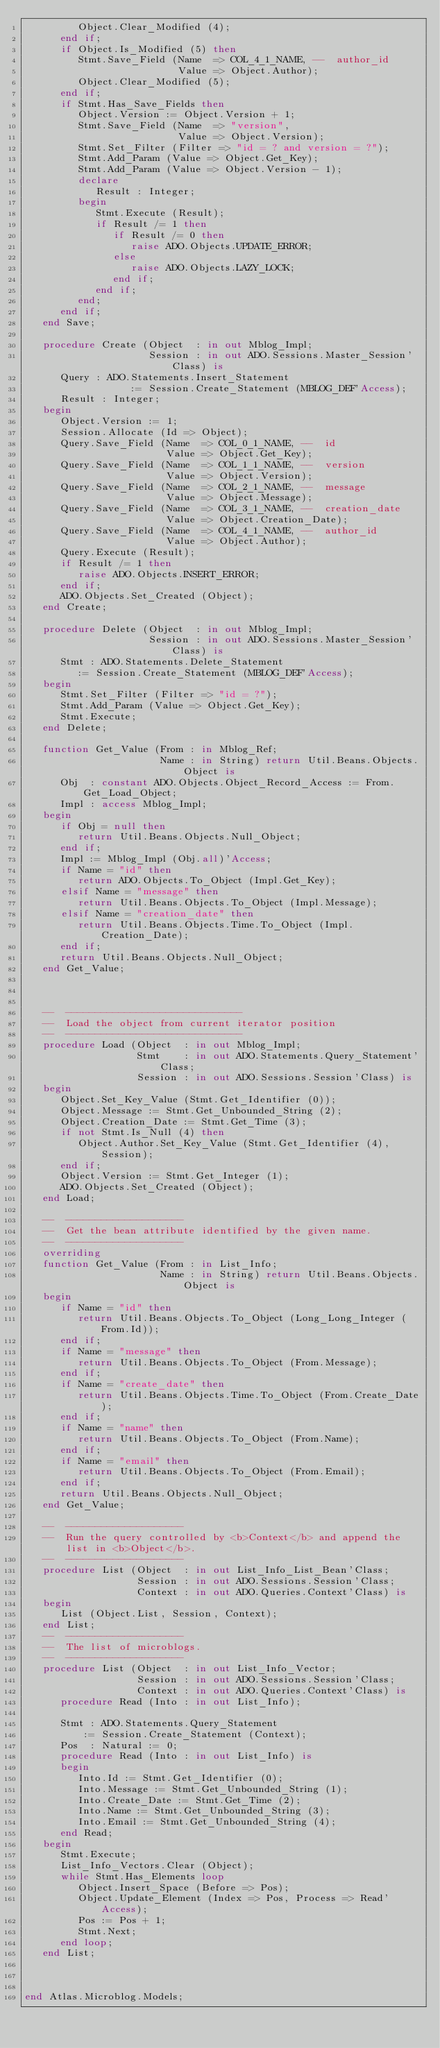Convert code to text. <code><loc_0><loc_0><loc_500><loc_500><_Ada_>         Object.Clear_Modified (4);
      end if;
      if Object.Is_Modified (5) then
         Stmt.Save_Field (Name  => COL_4_1_NAME, --  author_id
                          Value => Object.Author);
         Object.Clear_Modified (5);
      end if;
      if Stmt.Has_Save_Fields then
         Object.Version := Object.Version + 1;
         Stmt.Save_Field (Name  => "version",
                          Value => Object.Version);
         Stmt.Set_Filter (Filter => "id = ? and version = ?");
         Stmt.Add_Param (Value => Object.Get_Key);
         Stmt.Add_Param (Value => Object.Version - 1);
         declare
            Result : Integer;
         begin
            Stmt.Execute (Result);
            if Result /= 1 then
               if Result /= 0 then
                  raise ADO.Objects.UPDATE_ERROR;
               else
                  raise ADO.Objects.LAZY_LOCK;
               end if;
            end if;
         end;
      end if;
   end Save;

   procedure Create (Object  : in out Mblog_Impl;
                     Session : in out ADO.Sessions.Master_Session'Class) is
      Query : ADO.Statements.Insert_Statement
                  := Session.Create_Statement (MBLOG_DEF'Access);
      Result : Integer;
   begin
      Object.Version := 1;
      Session.Allocate (Id => Object);
      Query.Save_Field (Name  => COL_0_1_NAME, --  id
                        Value => Object.Get_Key);
      Query.Save_Field (Name  => COL_1_1_NAME, --  version
                        Value => Object.Version);
      Query.Save_Field (Name  => COL_2_1_NAME, --  message
                        Value => Object.Message);
      Query.Save_Field (Name  => COL_3_1_NAME, --  creation_date
                        Value => Object.Creation_Date);
      Query.Save_Field (Name  => COL_4_1_NAME, --  author_id
                        Value => Object.Author);
      Query.Execute (Result);
      if Result /= 1 then
         raise ADO.Objects.INSERT_ERROR;
      end if;
      ADO.Objects.Set_Created (Object);
   end Create;

   procedure Delete (Object  : in out Mblog_Impl;
                     Session : in out ADO.Sessions.Master_Session'Class) is
      Stmt : ADO.Statements.Delete_Statement
         := Session.Create_Statement (MBLOG_DEF'Access);
   begin
      Stmt.Set_Filter (Filter => "id = ?");
      Stmt.Add_Param (Value => Object.Get_Key);
      Stmt.Execute;
   end Delete;

   function Get_Value (From : in Mblog_Ref;
                       Name : in String) return Util.Beans.Objects.Object is
      Obj  : constant ADO.Objects.Object_Record_Access := From.Get_Load_Object;
      Impl : access Mblog_Impl;
   begin
      if Obj = null then
         return Util.Beans.Objects.Null_Object;
      end if;
      Impl := Mblog_Impl (Obj.all)'Access;
      if Name = "id" then
         return ADO.Objects.To_Object (Impl.Get_Key);
      elsif Name = "message" then
         return Util.Beans.Objects.To_Object (Impl.Message);
      elsif Name = "creation_date" then
         return Util.Beans.Objects.Time.To_Object (Impl.Creation_Date);
      end if;
      return Util.Beans.Objects.Null_Object;
   end Get_Value;



   --  ------------------------------
   --  Load the object from current iterator position
   --  ------------------------------
   procedure Load (Object  : in out Mblog_Impl;
                   Stmt    : in out ADO.Statements.Query_Statement'Class;
                   Session : in out ADO.Sessions.Session'Class) is
   begin
      Object.Set_Key_Value (Stmt.Get_Identifier (0));
      Object.Message := Stmt.Get_Unbounded_String (2);
      Object.Creation_Date := Stmt.Get_Time (3);
      if not Stmt.Is_Null (4) then
         Object.Author.Set_Key_Value (Stmt.Get_Identifier (4), Session);
      end if;
      Object.Version := Stmt.Get_Integer (1);
      ADO.Objects.Set_Created (Object);
   end Load;

   --  --------------------
   --  Get the bean attribute identified by the given name.
   --  --------------------
   overriding
   function Get_Value (From : in List_Info;
                       Name : in String) return Util.Beans.Objects.Object is
   begin
      if Name = "id" then
         return Util.Beans.Objects.To_Object (Long_Long_Integer (From.Id));
      end if;
      if Name = "message" then
         return Util.Beans.Objects.To_Object (From.Message);
      end if;
      if Name = "create_date" then
         return Util.Beans.Objects.Time.To_Object (From.Create_Date);
      end if;
      if Name = "name" then
         return Util.Beans.Objects.To_Object (From.Name);
      end if;
      if Name = "email" then
         return Util.Beans.Objects.To_Object (From.Email);
      end if;
      return Util.Beans.Objects.Null_Object;
   end Get_Value;

   --  --------------------
   --  Run the query controlled by <b>Context</b> and append the list in <b>Object</b>.
   --  --------------------
   procedure List (Object  : in out List_Info_List_Bean'Class;
                   Session : in out ADO.Sessions.Session'Class;
                   Context : in out ADO.Queries.Context'Class) is
   begin
      List (Object.List, Session, Context);
   end List;
   --  --------------------
   --  The list of microblogs.
   --  --------------------
   procedure List (Object  : in out List_Info_Vector;
                   Session : in out ADO.Sessions.Session'Class;
                   Context : in out ADO.Queries.Context'Class) is
      procedure Read (Into : in out List_Info);

      Stmt : ADO.Statements.Query_Statement
          := Session.Create_Statement (Context);
      Pos  : Natural := 0;
      procedure Read (Into : in out List_Info) is
      begin
         Into.Id := Stmt.Get_Identifier (0);
         Into.Message := Stmt.Get_Unbounded_String (1);
         Into.Create_Date := Stmt.Get_Time (2);
         Into.Name := Stmt.Get_Unbounded_String (3);
         Into.Email := Stmt.Get_Unbounded_String (4);
      end Read;
   begin
      Stmt.Execute;
      List_Info_Vectors.Clear (Object);
      while Stmt.Has_Elements loop
         Object.Insert_Space (Before => Pos);
         Object.Update_Element (Index => Pos, Process => Read'Access);
         Pos := Pos + 1;
         Stmt.Next;
      end loop;
   end List;



end Atlas.Microblog.Models;
</code> 